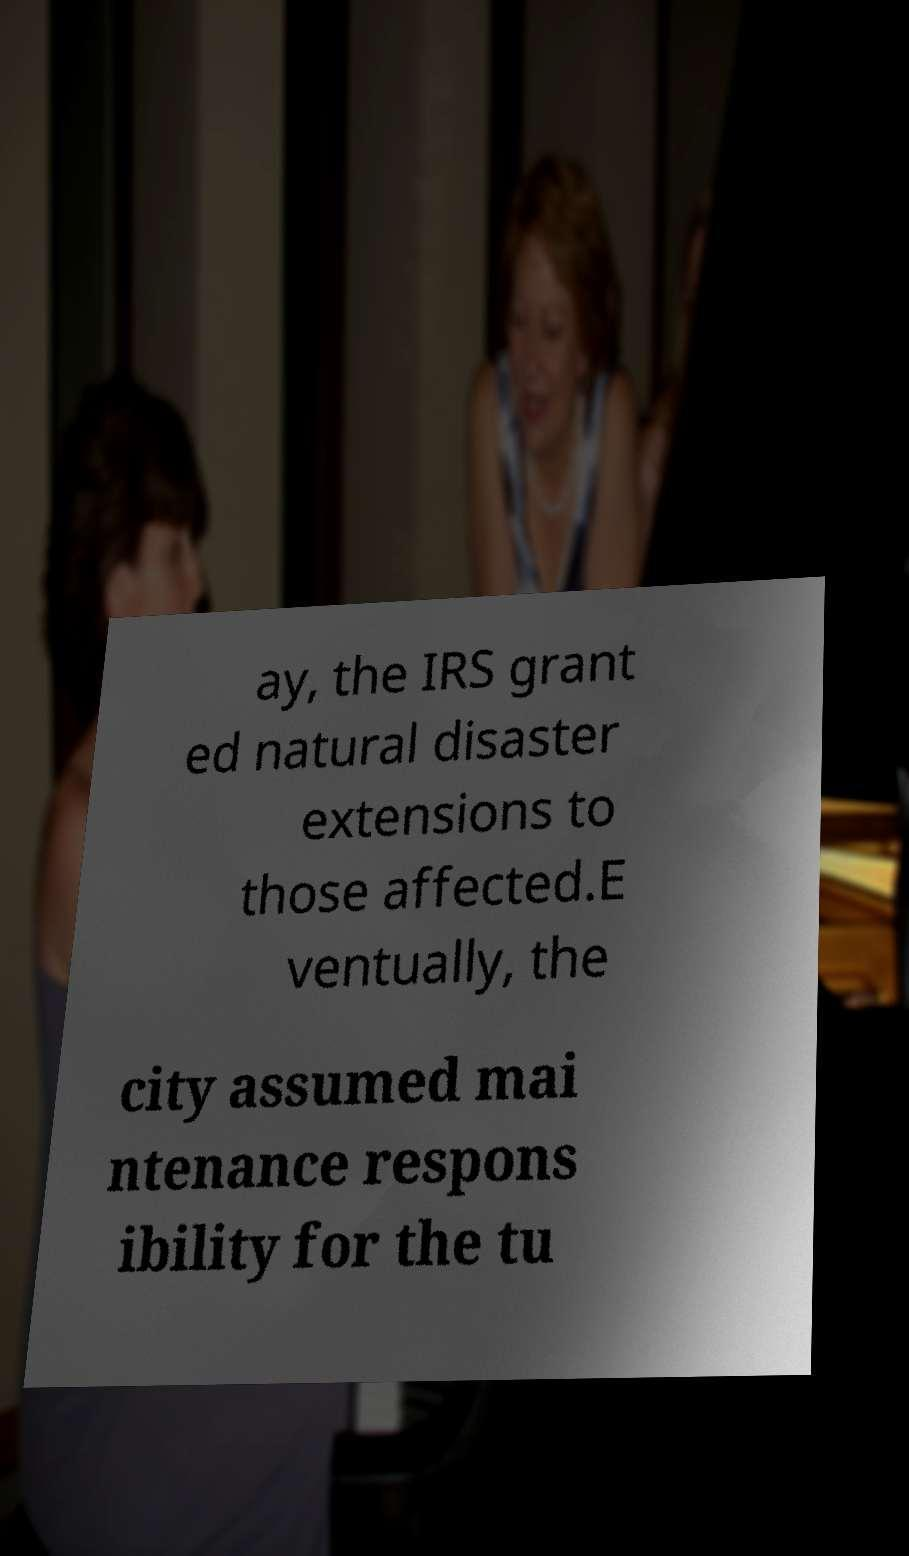What messages or text are displayed in this image? I need them in a readable, typed format. ay, the IRS grant ed natural disaster extensions to those affected.E ventually, the city assumed mai ntenance respons ibility for the tu 